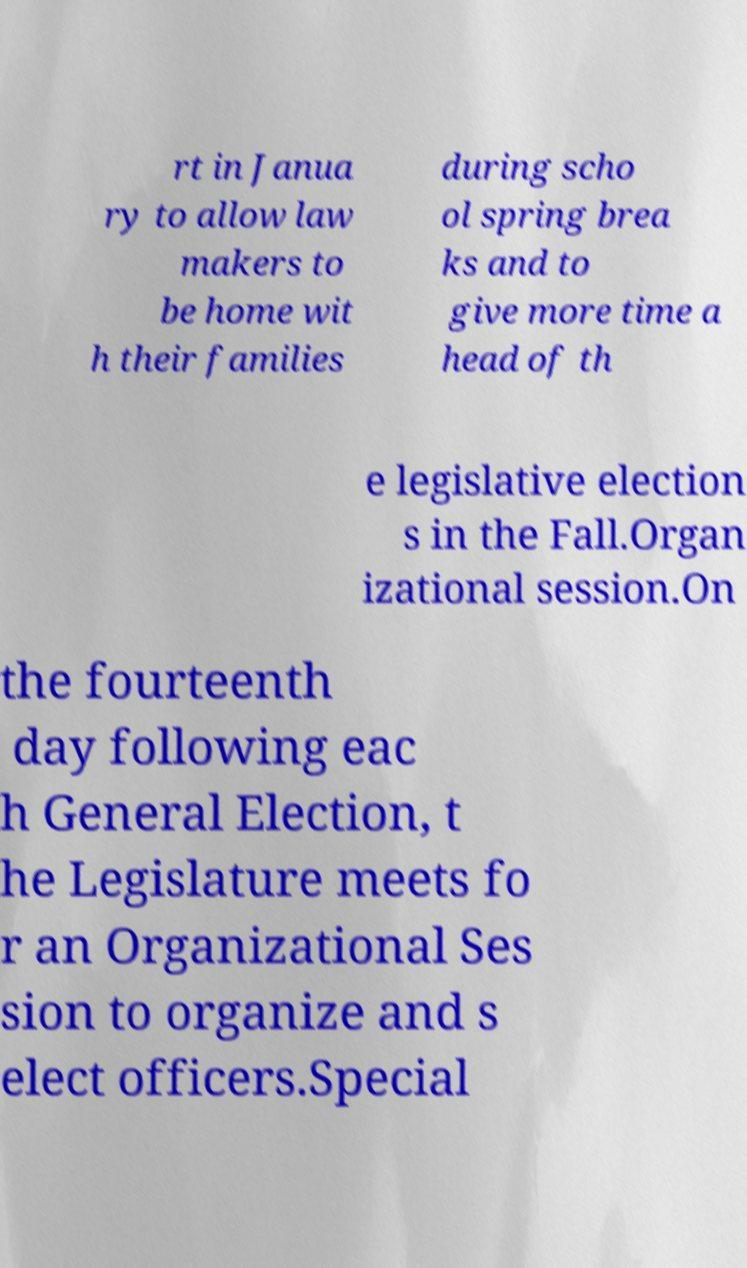Can you accurately transcribe the text from the provided image for me? rt in Janua ry to allow law makers to be home wit h their families during scho ol spring brea ks and to give more time a head of th e legislative election s in the Fall.Organ izational session.On the fourteenth day following eac h General Election, t he Legislature meets fo r an Organizational Ses sion to organize and s elect officers.Special 